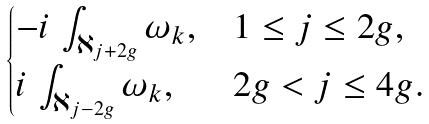Convert formula to latex. <formula><loc_0><loc_0><loc_500><loc_500>\begin{cases} - i \, \int _ { \aleph _ { j + 2 g } } \omega _ { k } , & 1 \leq j \leq 2 g , \\ i \, \int _ { \aleph _ { j - 2 g } } \omega _ { k } , & 2 g < j \leq 4 g . \end{cases}</formula> 